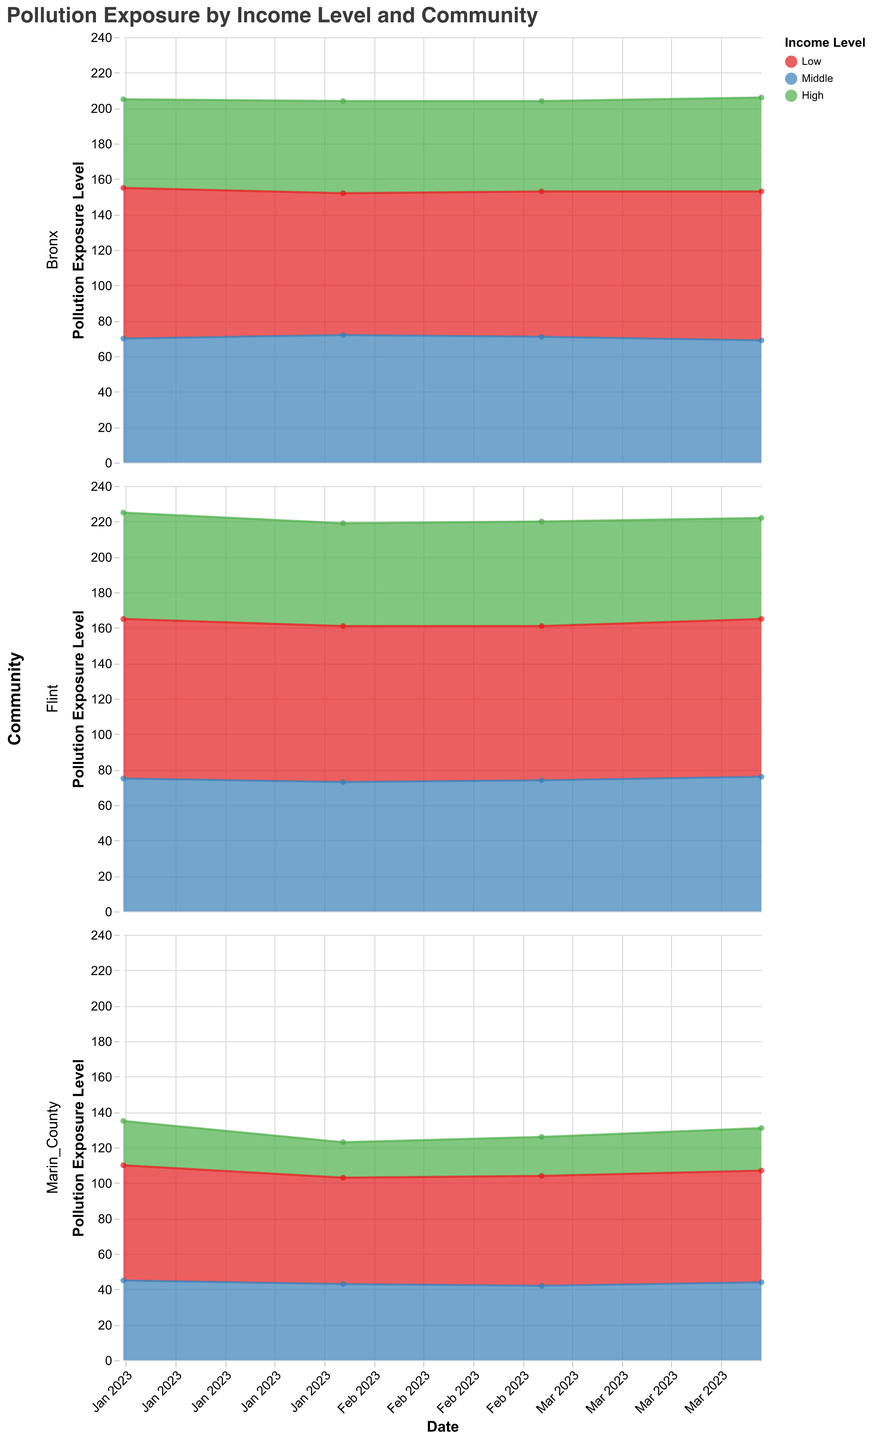What is the title of the figure? The title is usually placed at the top, and in this case, it reads "Pollution Exposure by Income Level and Community".
Answer: Pollution Exposure by Income Level and Community Which income level has the highest pollution exposure in Flint in January 2023? By looking at the shaded areas representing different income levels for Flint in January 2023, the area for 'Low' income level extends the highest.
Answer: Low How did the pollution exposure for the 'Middle' income level in Bronx change from January 2023 to February 2023? Compare the 'Middle' income level areas for Bronx on January 2023 and February 2023. In January, it was 70, and in February it increased to 72.
Answer: It increased Compare the pollution exposure levels for 'High' income level in Marin County and 'Middle' income level in Bronx on March 2023. Which is higher? Look at the y-values for 'High' income level in Marin County and 'Middle' income level in Bronx on March 2023. For Marin County (High), it's 22, and for Bronx (Middle), it's 71.
Answer: Bronx 'Middle' Which community shows the greatest overall variation in pollution exposure across all income levels and dates? Assess the width of the areas over different dates for each community. Flint shows large variations across the dates, indicating the highest overall variation.
Answer: Flint What is the pollution exposure level for 'Low' income level in Marin County in April 2023? Look at the data point where 'Low' income level intersects with April 2023 in Marin County. The value appears to be 63.
Answer: 63 Which income level generally has the lowest pollution exposure across all communities and dates? Observe the color-coded areas representing income levels across different communities and dates. The 'High' income level areas are consistently positioned lowest.
Answer: High For how many months data is represented in the figure? Count the number of distinct dates on the x-axis. The figure spans from January 2023 to April 2023, covering 4 months.
Answer: 4 months Considering only January 2023, rank the communities in descending order of pollution exposure for 'Low' income levels. Check the 'Low' income level section for January 2023 in each community. Flint (90) > Bronx (85) > Marin County (65).
Answer: Flint > Bronx > Marin County What is the average pollution exposure for the 'High' income level in Bronx over the entire time period? Find the 'High' income level pollution exposures for Bronx (50, 52, 51, 53). Calculate their sum (50 + 52 + 51 + 53 = 206). Divide by the count (4) to get the average: 206 / 4 = 51.5.
Answer: 51.5 